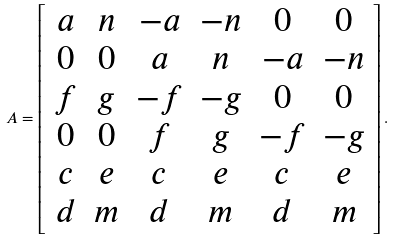Convert formula to latex. <formula><loc_0><loc_0><loc_500><loc_500>A = \left [ \begin{array} { c c c c c c } a & n & - a & - n & 0 & 0 \\ 0 & 0 & a & n & - a & - n \\ f & g & - f & - g & 0 & 0 \\ 0 & 0 & f & g & - f & - g \\ c & e & c & e & c & e \\ d & m & d & m & d & m \end{array} \right ] .</formula> 